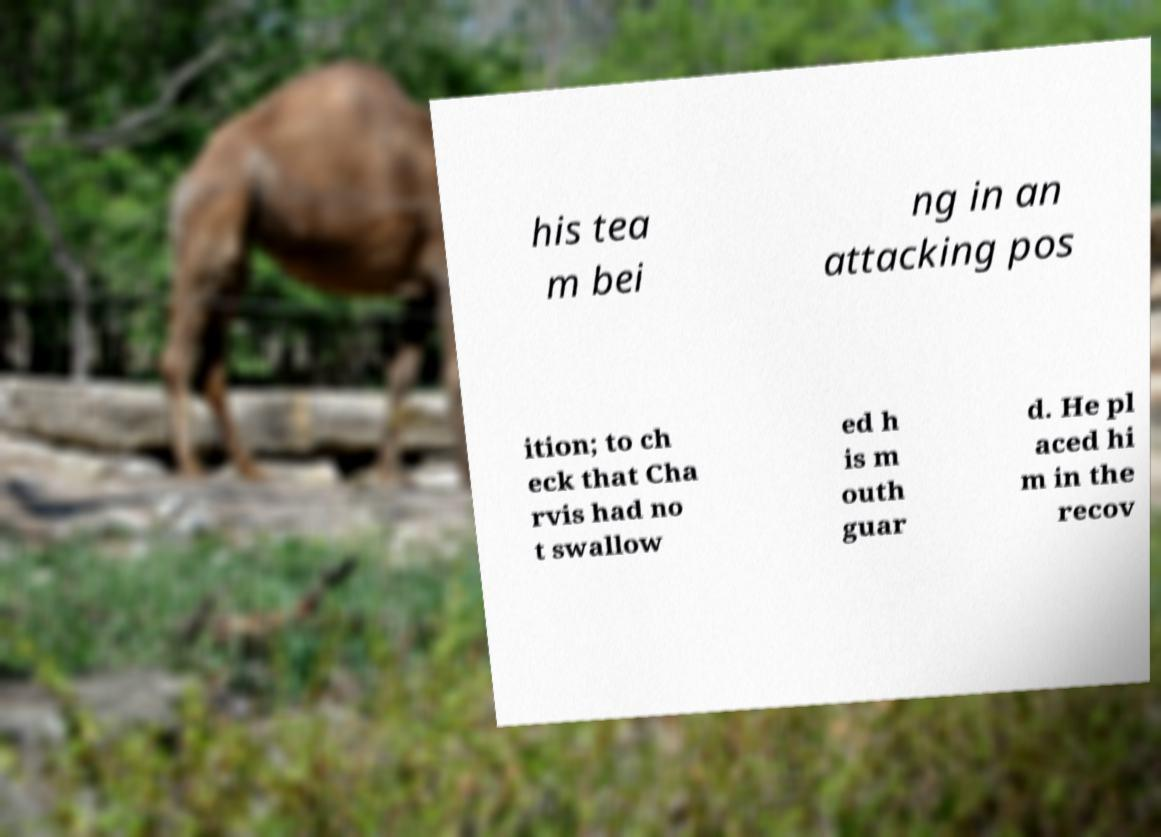There's text embedded in this image that I need extracted. Can you transcribe it verbatim? his tea m bei ng in an attacking pos ition; to ch eck that Cha rvis had no t swallow ed h is m outh guar d. He pl aced hi m in the recov 